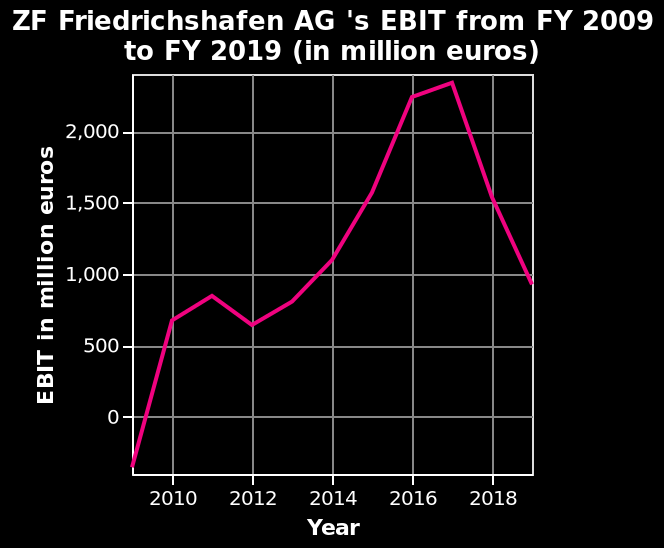<image>
Offer a thorough analysis of the image. The chart shows there have been 3 years of decline in growth, the most significant between 2017-2019 where it has almost halved in that period of time. By how much did the growth almost halve in the significant period mentioned?  The growth almost halved in the period between 2017-2019. What is the unit of measurement for the EBIT values in this line diagram? The unit of measurement for the EBIT values is in million euros. 